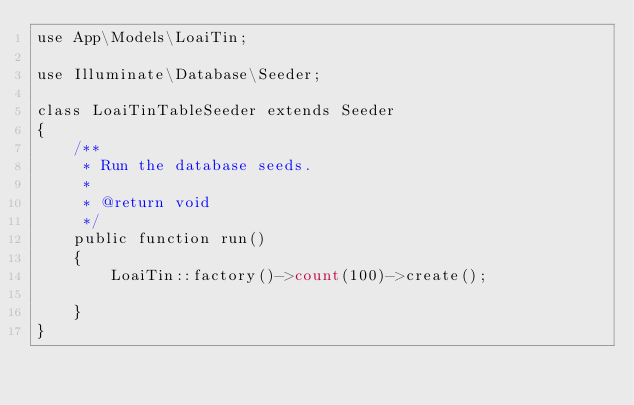Convert code to text. <code><loc_0><loc_0><loc_500><loc_500><_PHP_>use App\Models\LoaiTin;

use Illuminate\Database\Seeder;

class LoaiTinTableSeeder extends Seeder
{
    /**
     * Run the database seeds.
     *
     * @return void
     */
    public function run()
    {
        LoaiTin::factory()->count(100)->create();

    }
}
</code> 